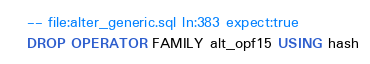Convert code to text. <code><loc_0><loc_0><loc_500><loc_500><_SQL_>-- file:alter_generic.sql ln:383 expect:true
DROP OPERATOR FAMILY alt_opf15 USING hash
</code> 